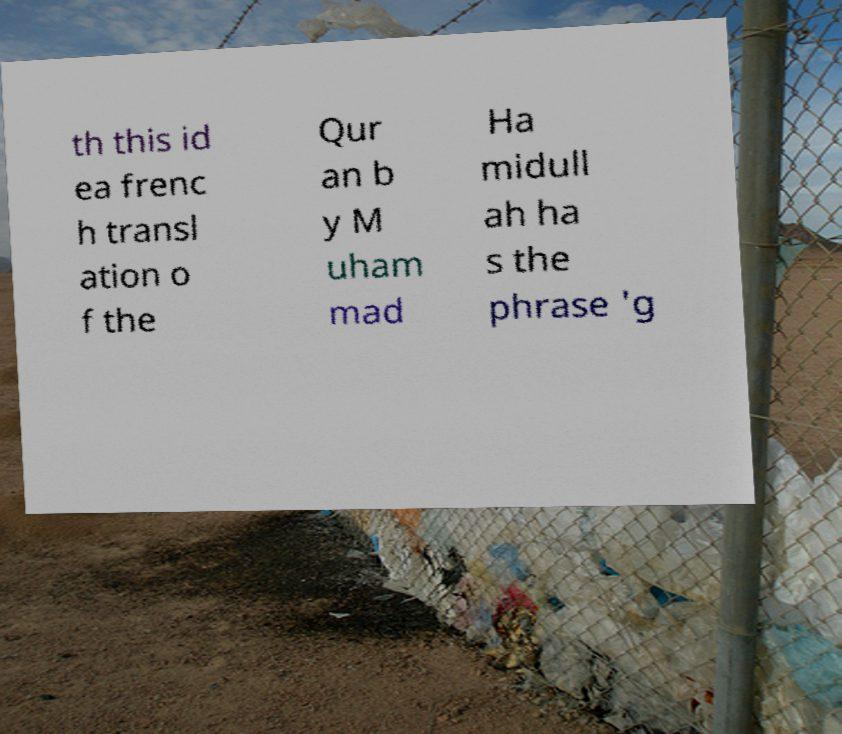Could you extract and type out the text from this image? th this id ea frenc h transl ation o f the Qur an b y M uham mad Ha midull ah ha s the phrase 'g 